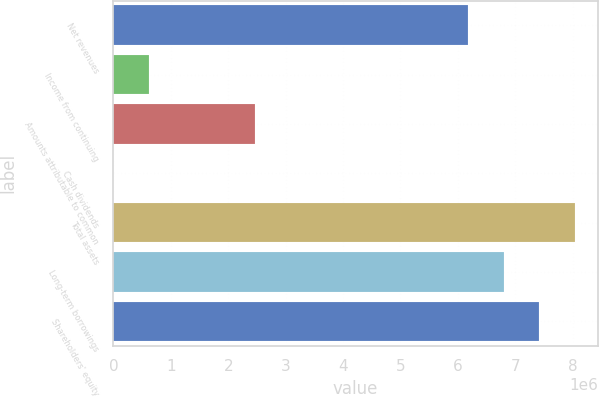<chart> <loc_0><loc_0><loc_500><loc_500><bar_chart><fcel>Net revenues<fcel>Income from continuing<fcel>Amounts attributable to common<fcel>Cash dividends<fcel>Total assets<fcel>Long-term borrowings<fcel>Shareholders' equity<nl><fcel>6.18149e+06<fcel>618150<fcel>2.4726e+06<fcel>1.36<fcel>8.03594e+06<fcel>6.79964e+06<fcel>7.41779e+06<nl></chart> 